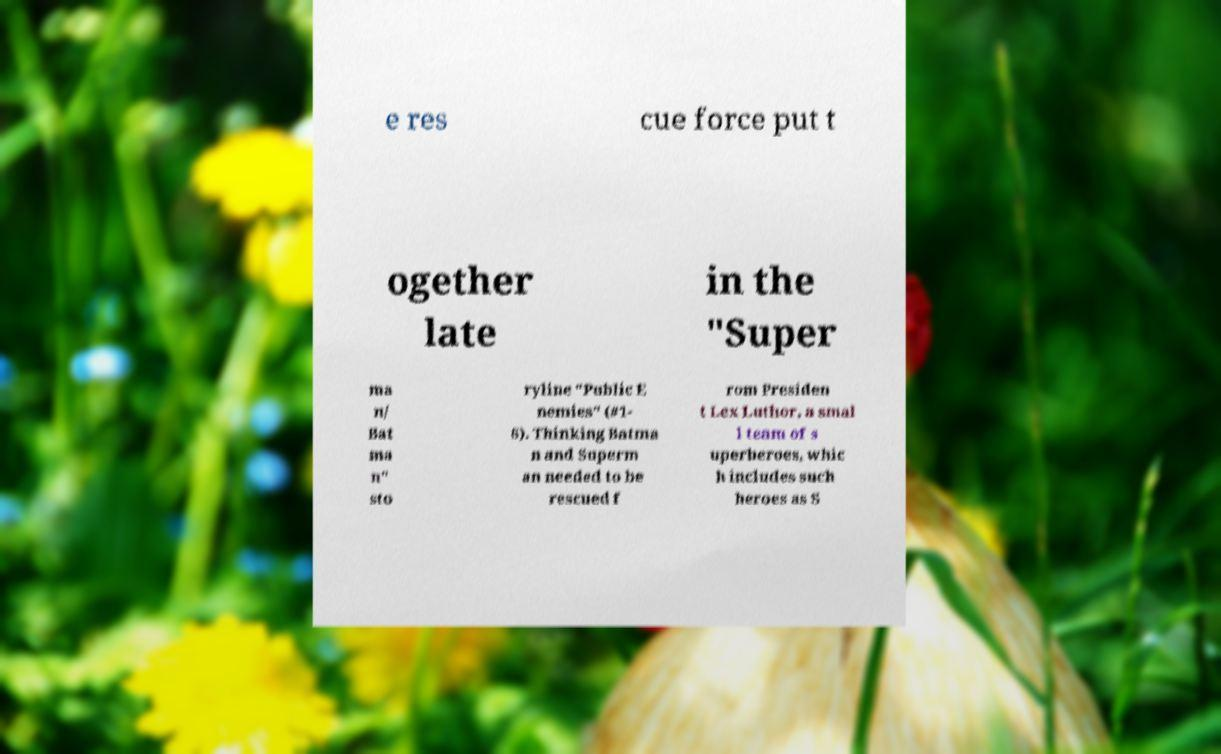Could you extract and type out the text from this image? e res cue force put t ogether late in the "Super ma n/ Bat ma n" sto ryline "Public E nemies" (#1- 6). Thinking Batma n and Superm an needed to be rescued f rom Presiden t Lex Luthor, a smal l team of s uperheroes, whic h includes such heroes as S 